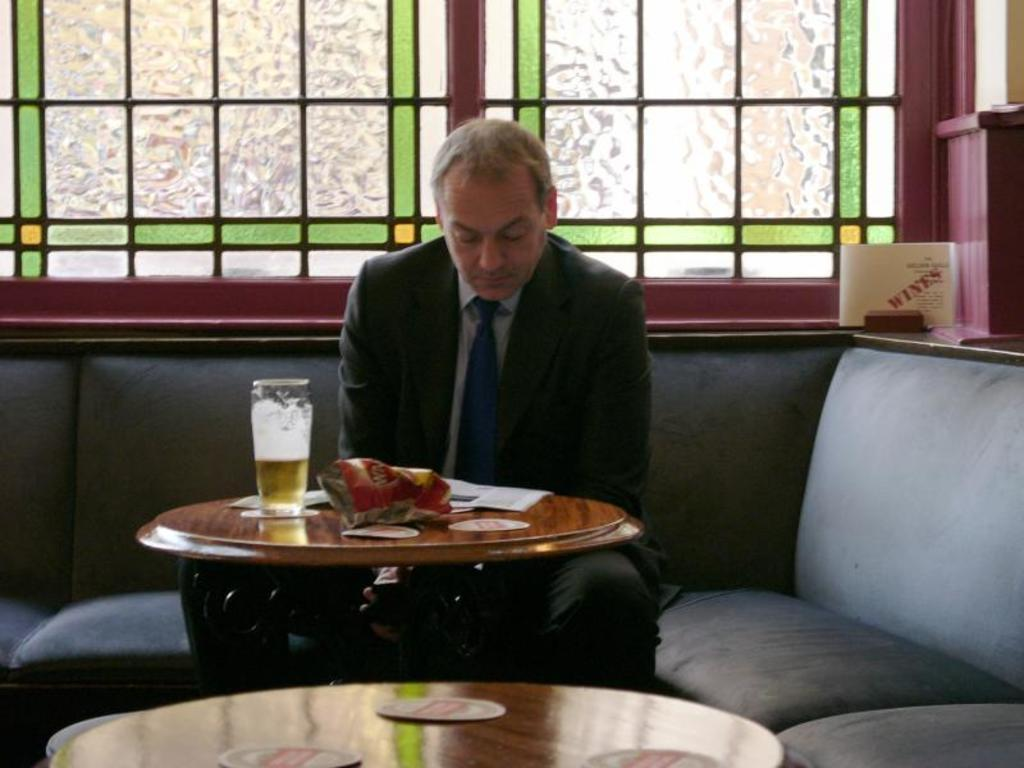What is the man in the image doing? The man is sitting on a couch. What objects are on the table in the image? There are papers and a glass on a table. What can be seen in the background of the image? There is a window in the background. How many accounts does the man have in the image? There is no mention of accounts in the image. 